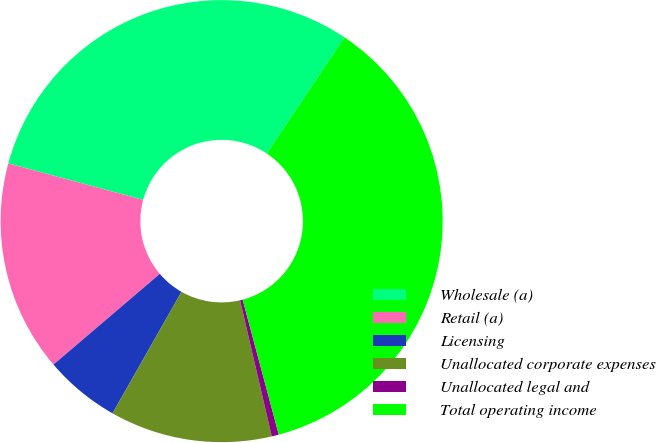Convert chart to OTSL. <chart><loc_0><loc_0><loc_500><loc_500><pie_chart><fcel>Wholesale (a)<fcel>Retail (a)<fcel>Licensing<fcel>Unallocated corporate expenses<fcel>Unallocated legal and<fcel>Total operating income<nl><fcel>30.18%<fcel>15.45%<fcel>5.54%<fcel>11.86%<fcel>0.52%<fcel>36.46%<nl></chart> 